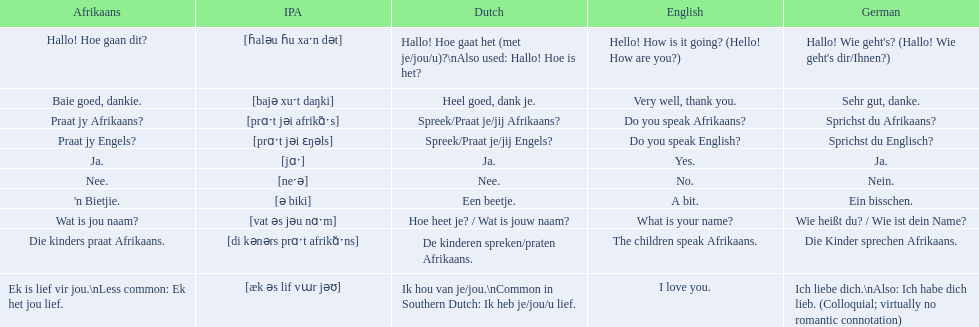What are the afrikaans idioms? Hallo! Hoe gaan dit?, Baie goed, dankie., Praat jy Afrikaans?, Praat jy Engels?, Ja., Nee., 'n Bietjie., Wat is jou naam?, Die kinders praat Afrikaans., Ek is lief vir jou.\nLess common: Ek het jou lief. Could you parse the entire table? {'header': ['Afrikaans', 'IPA', 'Dutch', 'English', 'German'], 'rows': [['Hallo! Hoe gaan dit?', '[ɦaləu ɦu xaˑn dət]', 'Hallo! Hoe gaat het (met je/jou/u)?\\nAlso used: Hallo! Hoe is het?', 'Hello! How is it going? (Hello! How are you?)', "Hallo! Wie geht's? (Hallo! Wie geht's dir/Ihnen?)"], ['Baie goed, dankie.', '[bajə xuˑt daŋki]', 'Heel goed, dank je.', 'Very well, thank you.', 'Sehr gut, danke.'], ['Praat jy Afrikaans?', '[prɑˑt jəi afrikɑ̃ˑs]', 'Spreek/Praat je/jij Afrikaans?', 'Do you speak Afrikaans?', 'Sprichst du Afrikaans?'], ['Praat jy Engels?', '[prɑˑt jəi ɛŋəls]', 'Spreek/Praat je/jij Engels?', 'Do you speak English?', 'Sprichst du Englisch?'], ['Ja.', '[jɑˑ]', 'Ja.', 'Yes.', 'Ja.'], ['Nee.', '[neˑə]', 'Nee.', 'No.', 'Nein.'], ["'n Bietjie.", '[ə biki]', 'Een beetje.', 'A bit.', 'Ein bisschen.'], ['Wat is jou naam?', '[vat əs jəu nɑˑm]', 'Hoe heet je? / Wat is jouw naam?', 'What is your name?', 'Wie heißt du? / Wie ist dein Name?'], ['Die kinders praat Afrikaans.', '[di kənərs prɑˑt afrikɑ̃ˑns]', 'De kinderen spreken/praten Afrikaans.', 'The children speak Afrikaans.', 'Die Kinder sprechen Afrikaans.'], ['Ek is lief vir jou.\\nLess common: Ek het jou lief.', '[æk əs lif vɯr jəʊ]', 'Ik hou van je/jou.\\nCommon in Southern Dutch: Ik heb je/jou/u lief.', 'I love you.', 'Ich liebe dich.\\nAlso: Ich habe dich lieb. (Colloquial; virtually no romantic connotation)']]} For "die kinders praat afrikaans," what are the translation possibilities? De kinderen spreken/praten Afrikaans., The children speak Afrikaans., Die Kinder sprechen Afrikaans. Which one is the german translation? Die Kinder sprechen Afrikaans. 